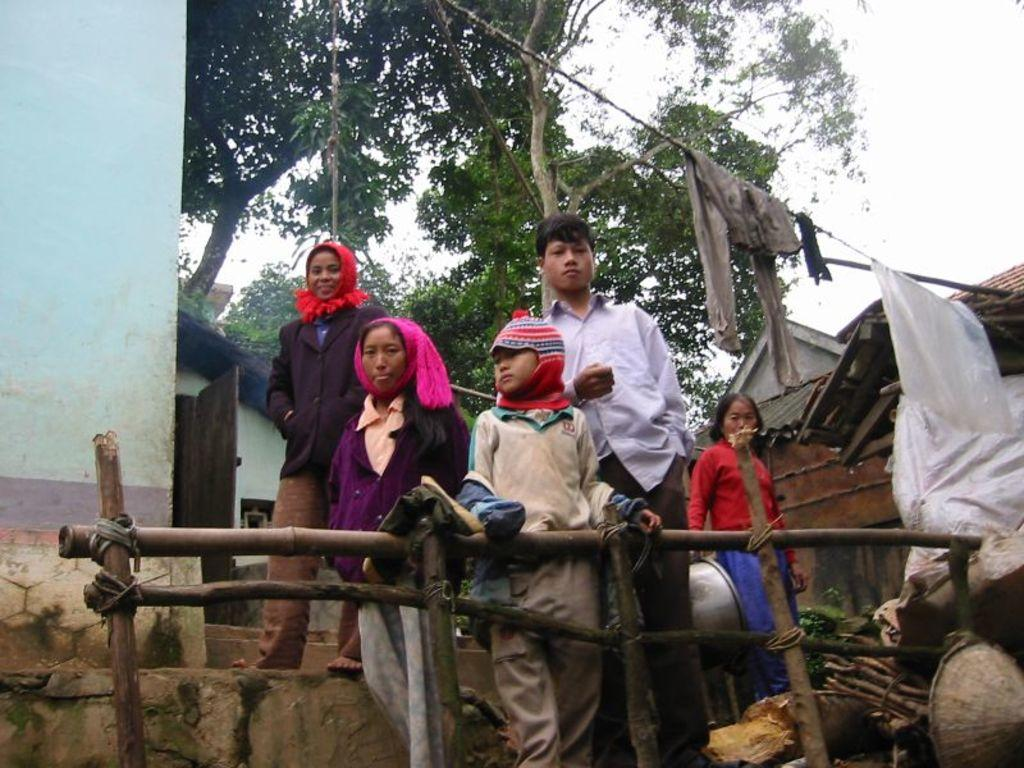What can be seen in the background of the image? There is a sky and trees visible in the background of the image. What type of structures are present in the image? There are houses in the image, and rooftops are also visible. What objects are related to clothing in the image? Clothes are visible in the image, and there is a door as well. What architectural feature is present in the image? A wooden railing is present in the image. What additional object can be seen in the image? There is a rope in the image. Are there any people in the image? Yes, people are standing in the image. How does the giraffe compare to the houses in the image? There is no giraffe present in the image, so it cannot be compared to the houses. What type of zipper can be seen on the clothes in the image? There is no mention of a zipper on the clothes in the image, so it cannot be described. 